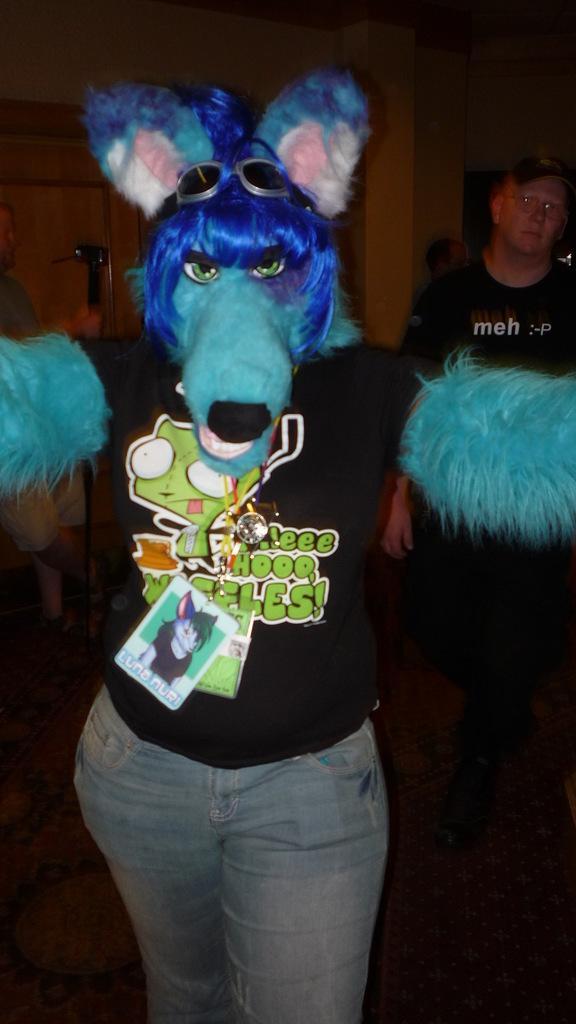How would you summarize this image in a sentence or two? In the image we can see there is a person standing and she is wearing head mask and id card. Behind there is another man standing. 